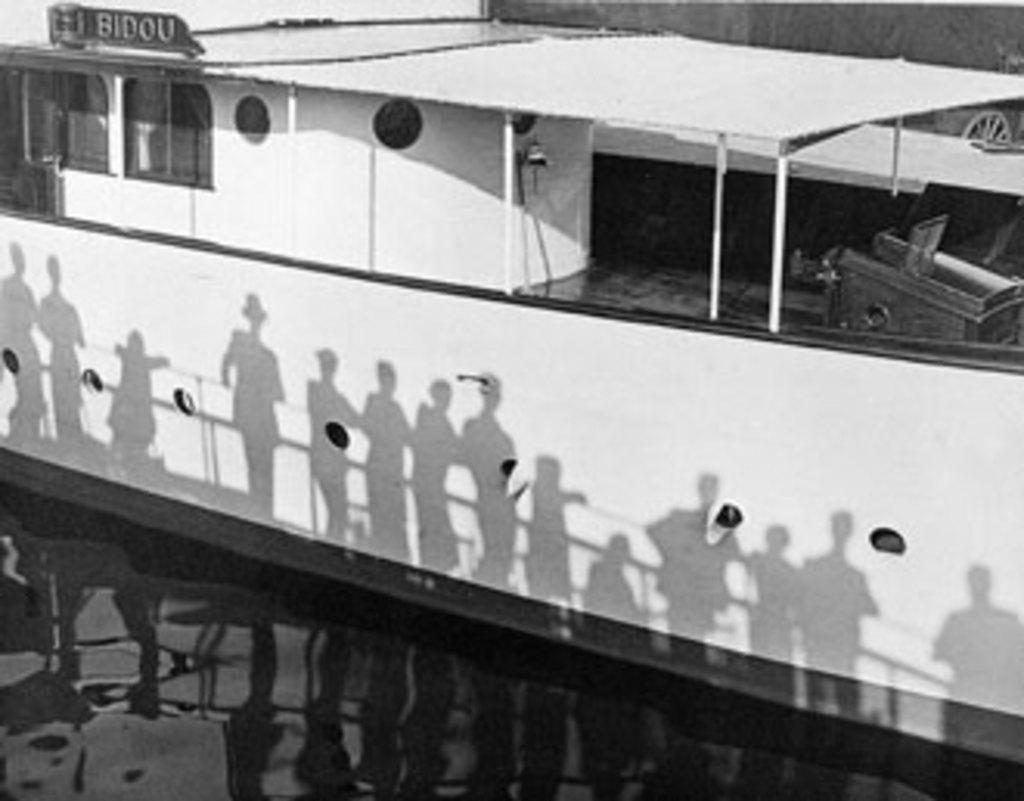<image>
Relay a brief, clear account of the picture shown. A boat called Bidou has shadows along the side exterior 